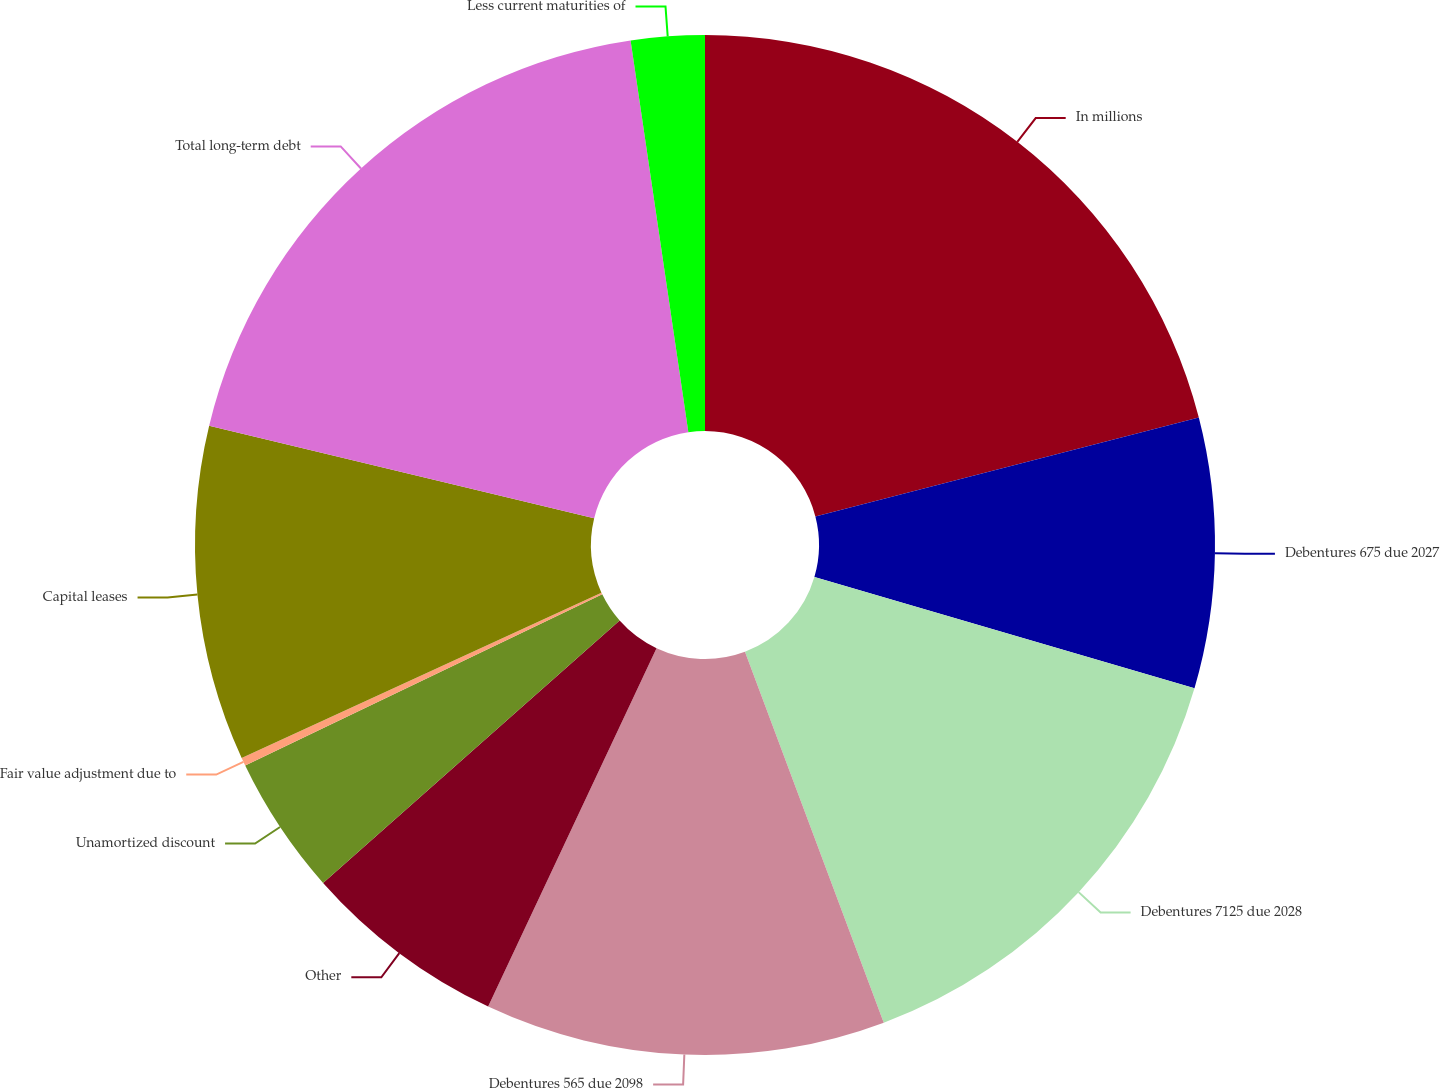Convert chart. <chart><loc_0><loc_0><loc_500><loc_500><pie_chart><fcel>In millions<fcel>Debentures 675 due 2027<fcel>Debentures 7125 due 2028<fcel>Debentures 565 due 2098<fcel>Other<fcel>Unamortized discount<fcel>Fair value adjustment due to<fcel>Capital leases<fcel>Total long-term debt<fcel>Less current maturities of<nl><fcel>20.98%<fcel>8.55%<fcel>14.77%<fcel>12.69%<fcel>6.48%<fcel>4.41%<fcel>0.26%<fcel>10.62%<fcel>18.91%<fcel>2.33%<nl></chart> 